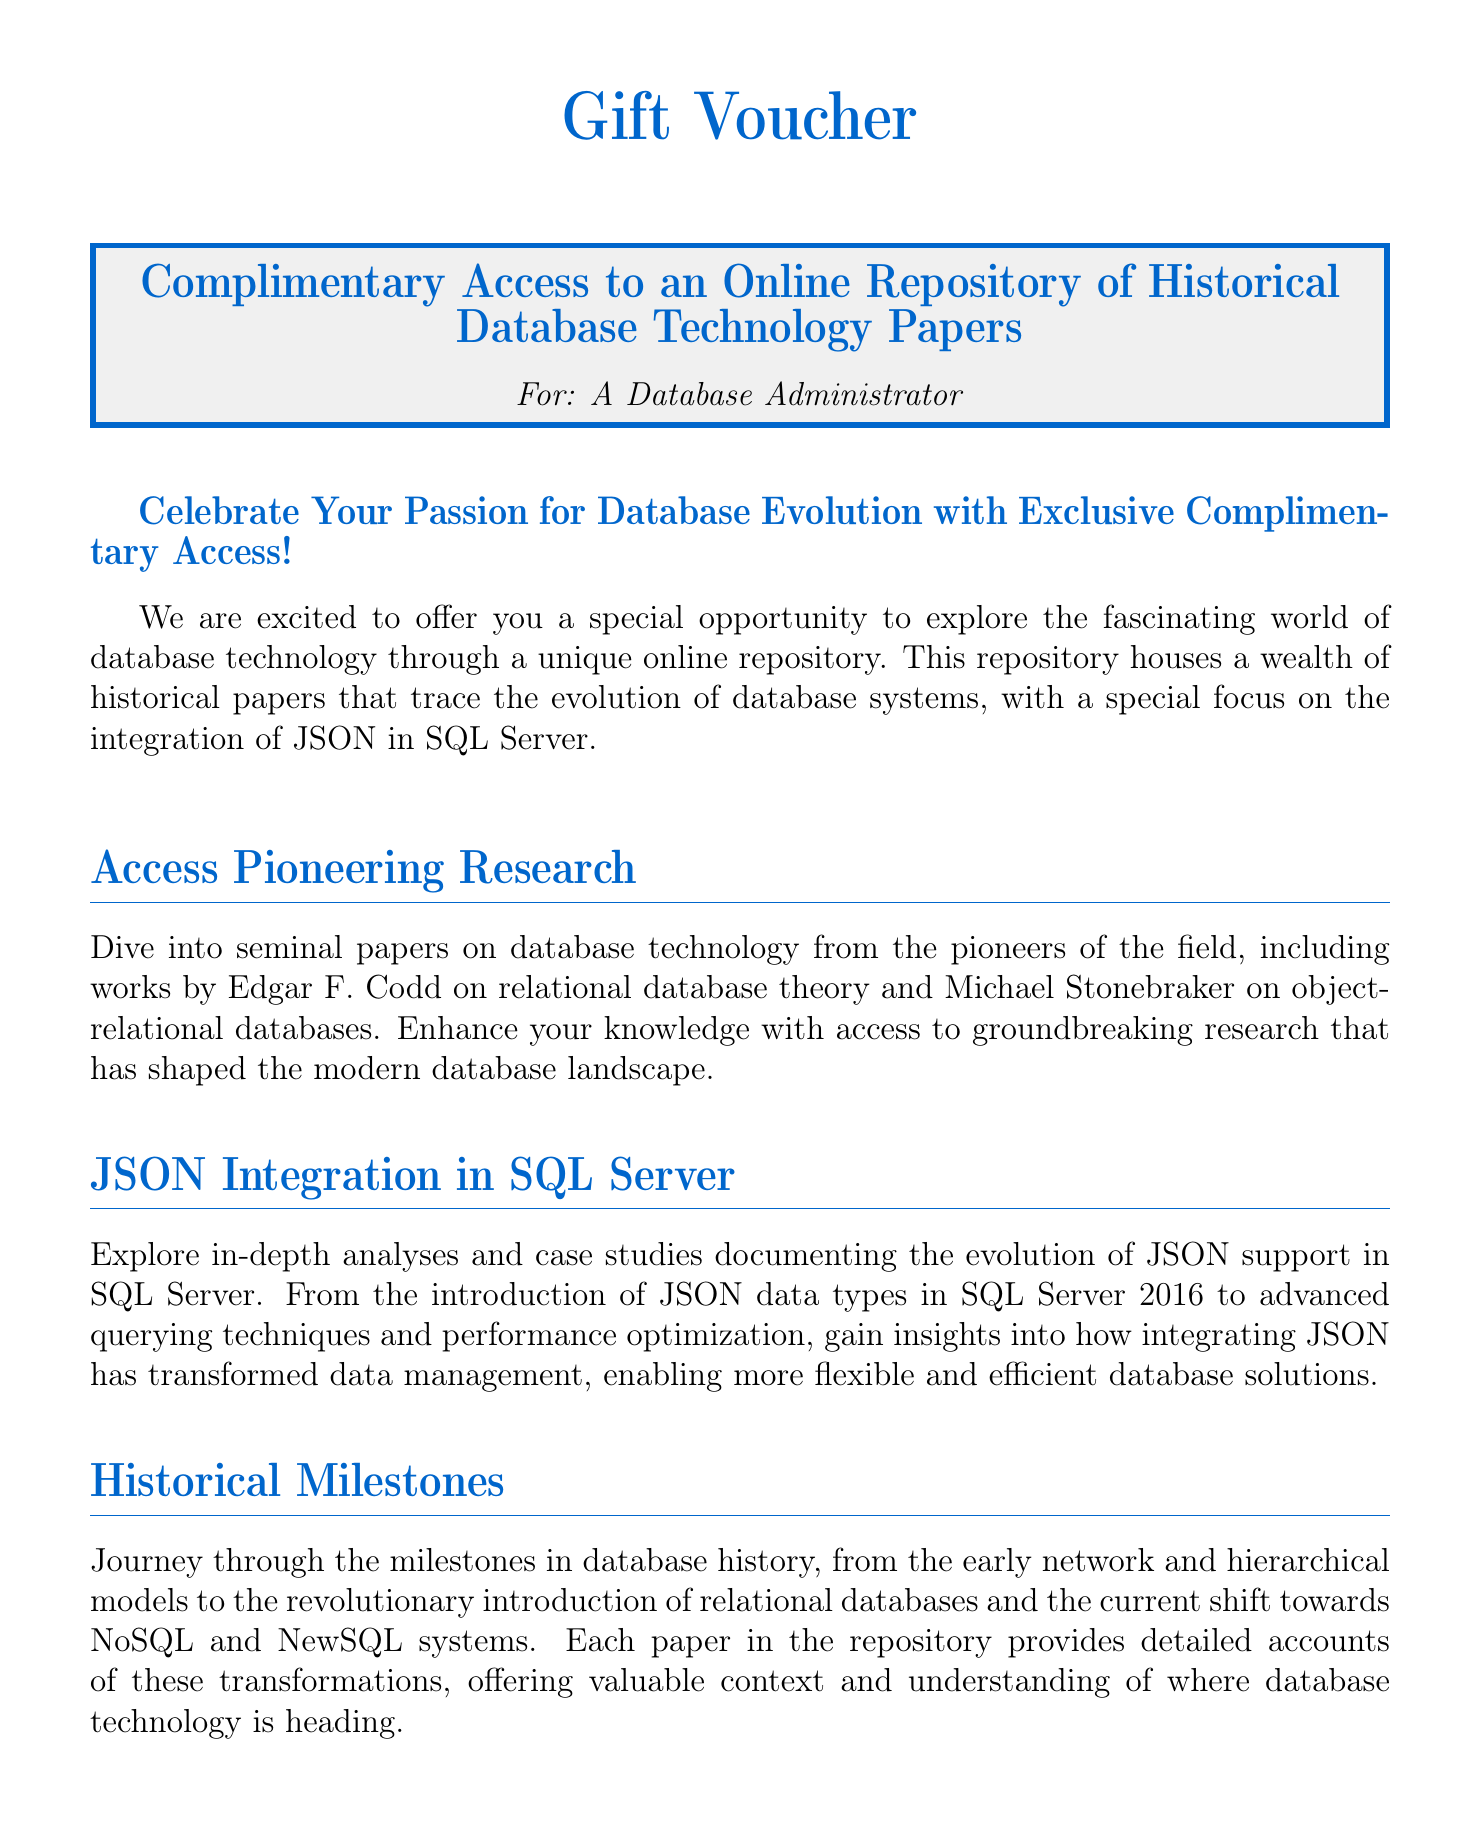What is the title of the document? The title of the document is presented prominently at the beginning.
Answer: Gift Voucher Who is this gift voucher for? The document specifies the recipient of the voucher clearly.
Answer: A Database Administrator What year was JSON data type introduced in SQL Server? The document mentions the introduction of JSON data types in a specific year.
Answer: 2016 Which pioneering researcher is mentioned in relation to relational database theory? The document highlights significant contributors to the field of database technology.
Answer: Edgar F. Codd What color is used for the section titles? The document uses a specific color for section titles, which is indicated visually.
Answer: dbblue What does the voucher grant access to? The primary offering of the voucher is clearly stated in the document.
Answer: An Online Repository of Historical Database Technology Papers What topic is emphasized in the document? The document focuses on a particular aspect of database technology evolution.
Answer: Integration of JSON in SQL Server What type of expert contributions are included in the repository? The document describes the type of expert insights available within the repository.
Answer: Analyses What is the background color of the voucher frame? The document specifies the background color used in the framing of the voucher.
Answer: dbgray 